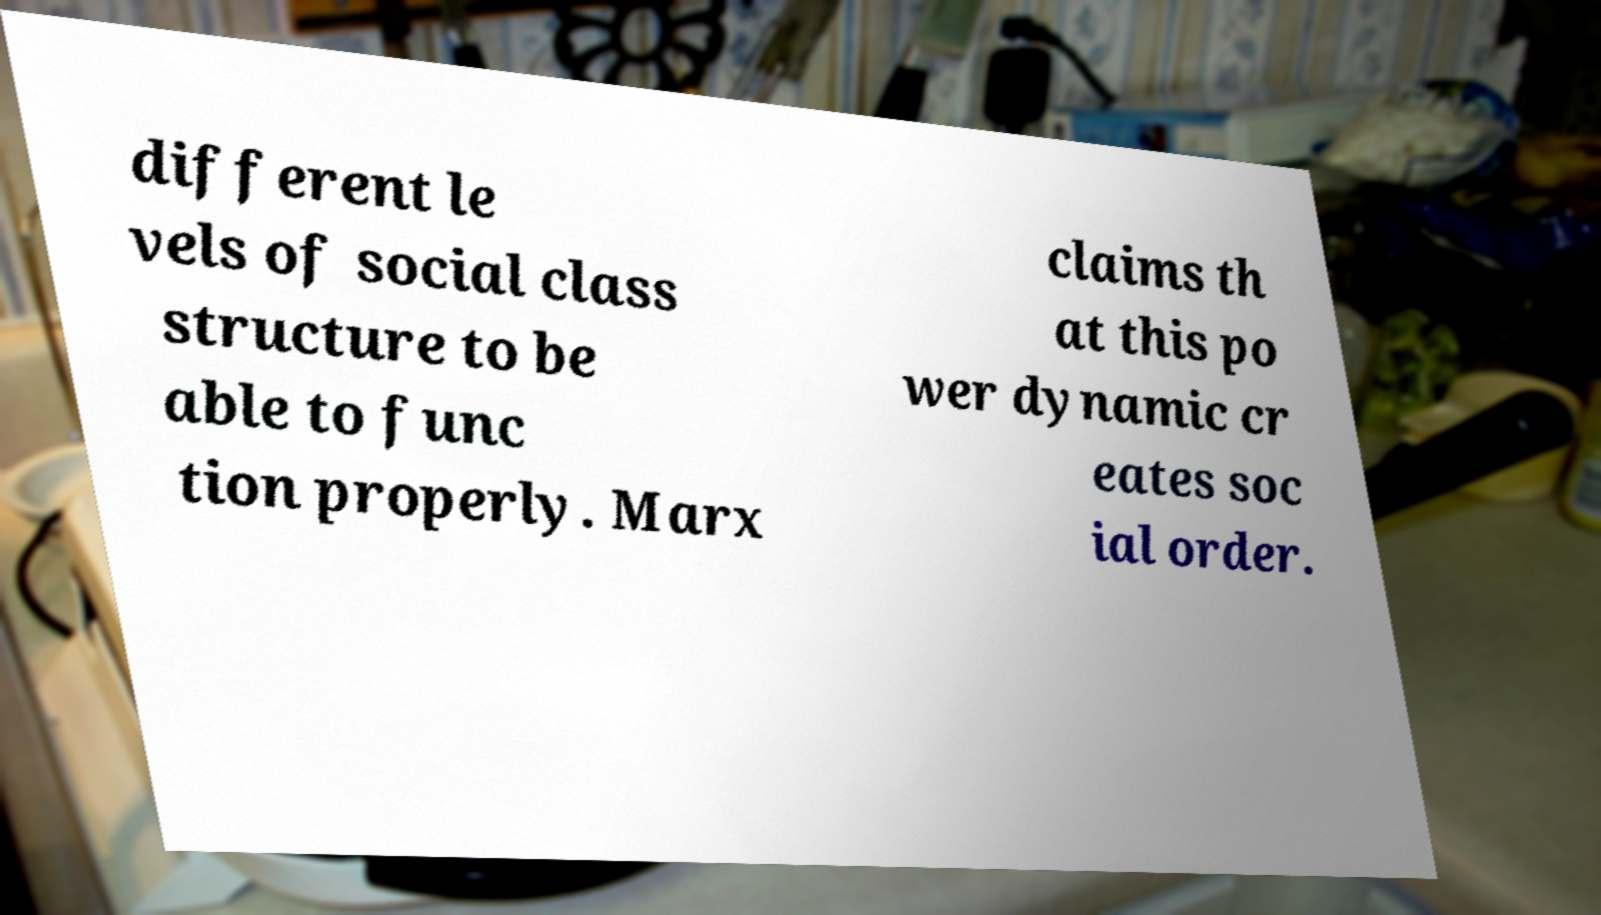For documentation purposes, I need the text within this image transcribed. Could you provide that? different le vels of social class structure to be able to func tion properly. Marx claims th at this po wer dynamic cr eates soc ial order. 